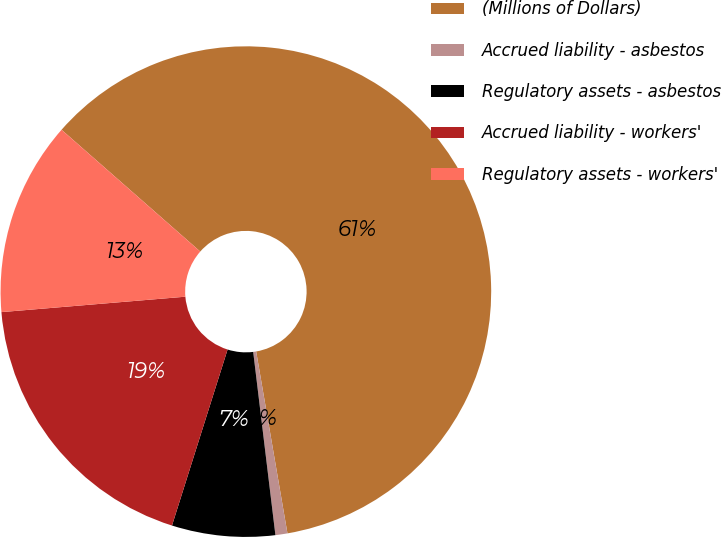Convert chart to OTSL. <chart><loc_0><loc_0><loc_500><loc_500><pie_chart><fcel>(Millions of Dollars)<fcel>Accrued liability - asbestos<fcel>Regulatory assets - asbestos<fcel>Accrued liability - workers'<fcel>Regulatory assets - workers'<nl><fcel>60.82%<fcel>0.79%<fcel>6.79%<fcel>18.8%<fcel>12.8%<nl></chart> 